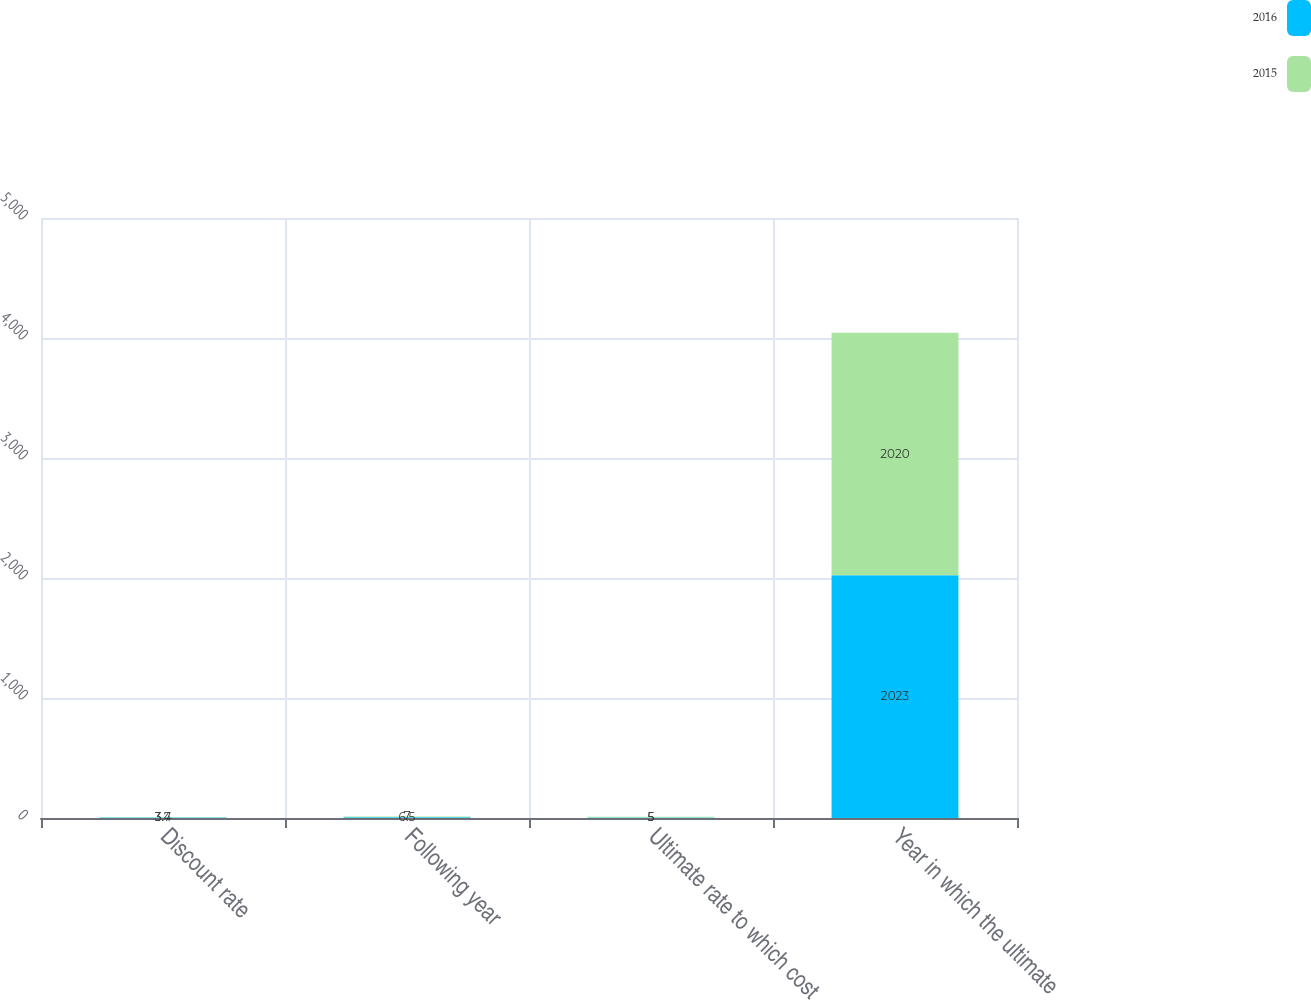Convert chart. <chart><loc_0><loc_0><loc_500><loc_500><stacked_bar_chart><ecel><fcel>Discount rate<fcel>Following year<fcel>Ultimate rate to which cost<fcel>Year in which the ultimate<nl><fcel>2016<fcel>3.4<fcel>6.5<fcel>5<fcel>2023<nl><fcel>2015<fcel>3.7<fcel>7<fcel>5<fcel>2020<nl></chart> 